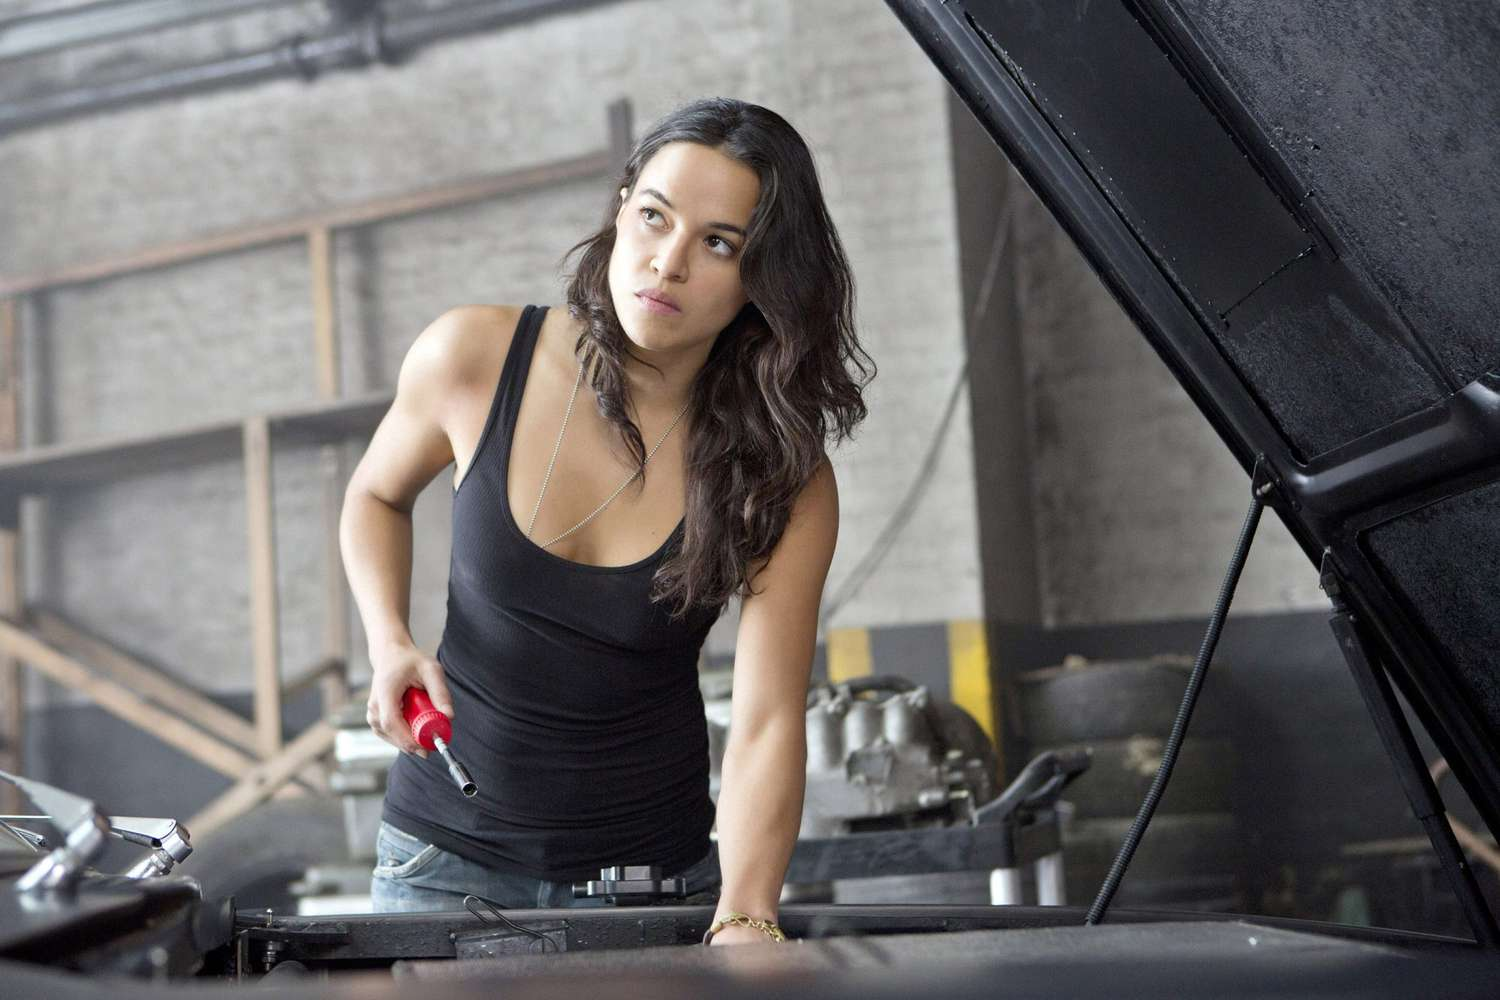Describe a realistic day in the life of this character in the image, with a focus on her work. The day starts early for her, with a strong cup of coffee in hand as she opens the garage doors. She runs a small, independent auto repair shop and takes great pride in her work. Her day is filled with a mix of scheduled appointments and urgent walk-ins. From simple oil changes to complex engine repairs, each task demands her full attention. She carefully diagnoses issues, orders parts, and sometimes fabricates solutions when parts are unavailable. Her clients know her for her meticulous work and honest advice. In between jobs, she manages paperwork, orders supplies, and keeps the workshop organized. Despite the long hours and physical demands, she finds satisfaction in solving problems and helping people get back on the road safely. 